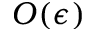<formula> <loc_0><loc_0><loc_500><loc_500>O ( \epsilon )</formula> 